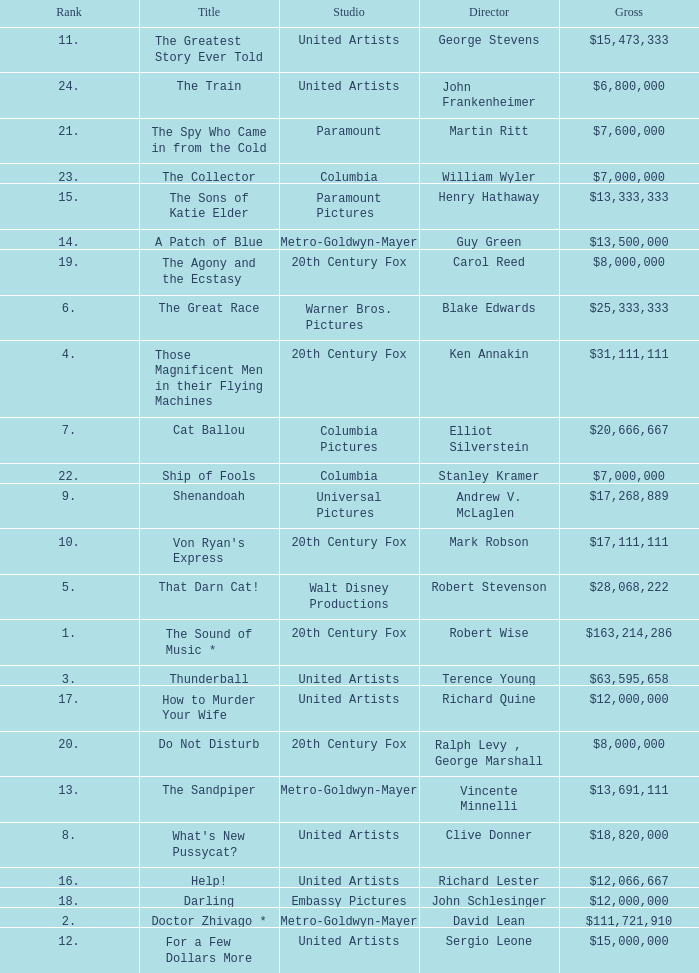What is the highest Rank, when Director is "Henry Hathaway"? 15.0. 